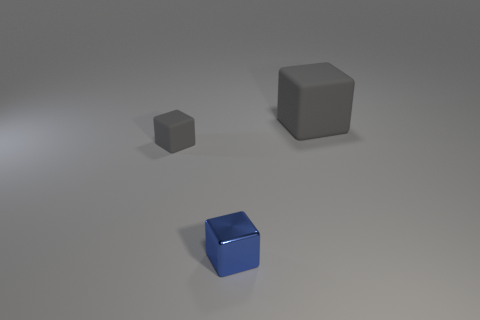Add 2 small blocks. How many objects exist? 5 Add 3 blue things. How many blue things are left? 4 Add 1 rubber blocks. How many rubber blocks exist? 3 Subtract 0 green cylinders. How many objects are left? 3 Subtract all gray shiny cylinders. Subtract all small gray cubes. How many objects are left? 2 